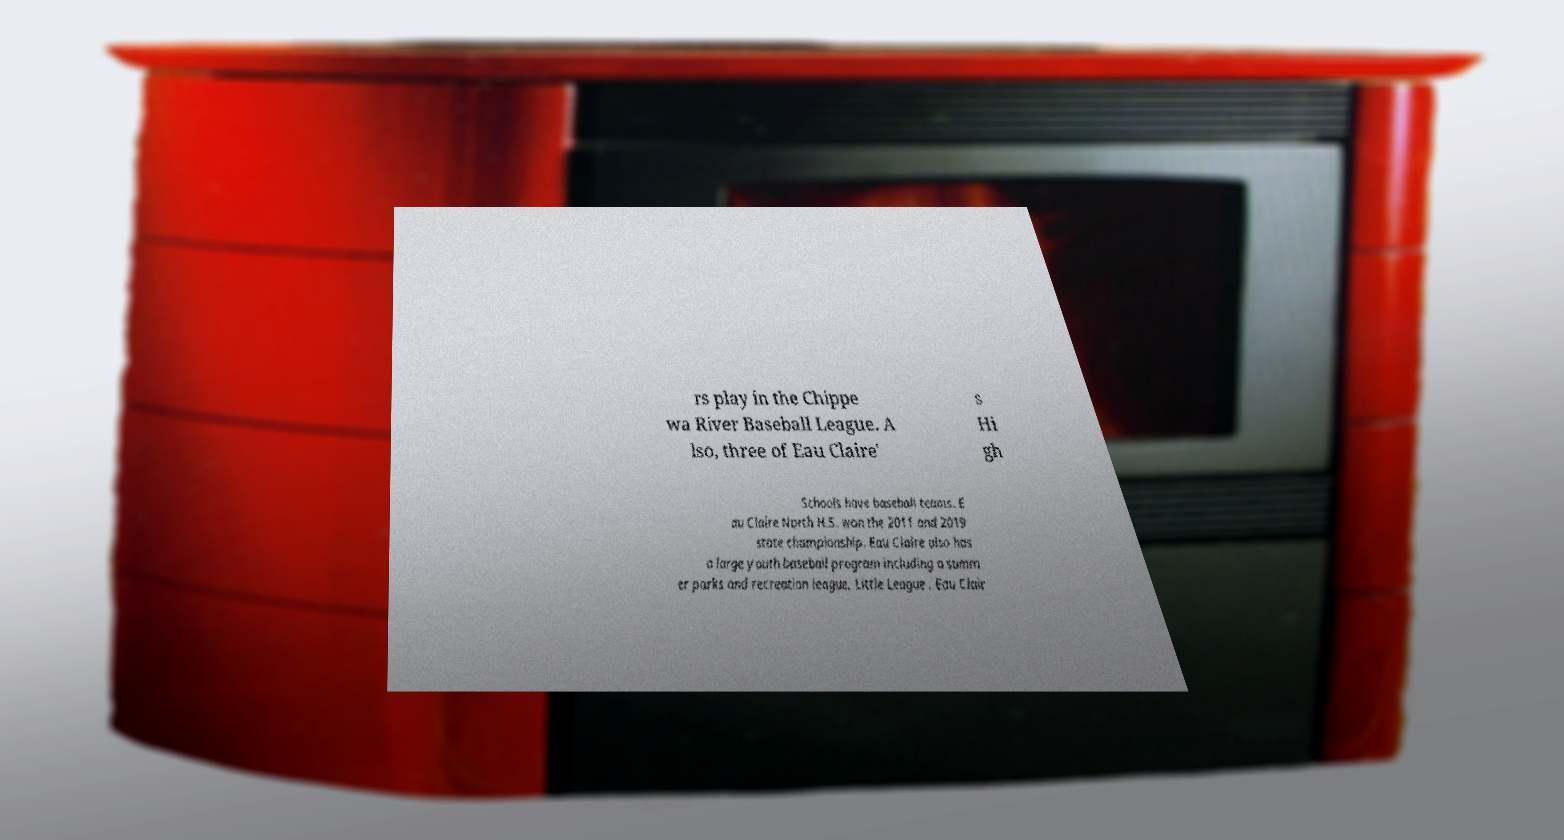Please read and relay the text visible in this image. What does it say? rs play in the Chippe wa River Baseball League. A lso, three of Eau Claire' s Hi gh Schools have baseball teams. E au Claire North H.S. won the 2011 and 2019 state championship. Eau Claire also has a large youth baseball program including a summ er parks and recreation league, Little League . Eau Clair 